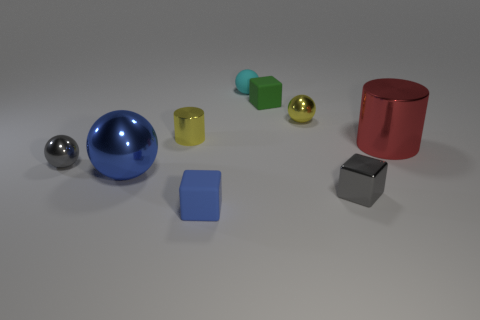Subtract all small balls. How many balls are left? 1 Add 1 blue objects. How many objects exist? 10 Subtract all gray balls. How many balls are left? 3 Subtract 2 balls. How many balls are left? 2 Add 7 large blocks. How many large blocks exist? 7 Subtract 0 green cylinders. How many objects are left? 9 Subtract all cubes. How many objects are left? 6 Subtract all purple blocks. Subtract all gray spheres. How many blocks are left? 3 Subtract all small gray objects. Subtract all small gray metallic cubes. How many objects are left? 6 Add 1 gray metal blocks. How many gray metal blocks are left? 2 